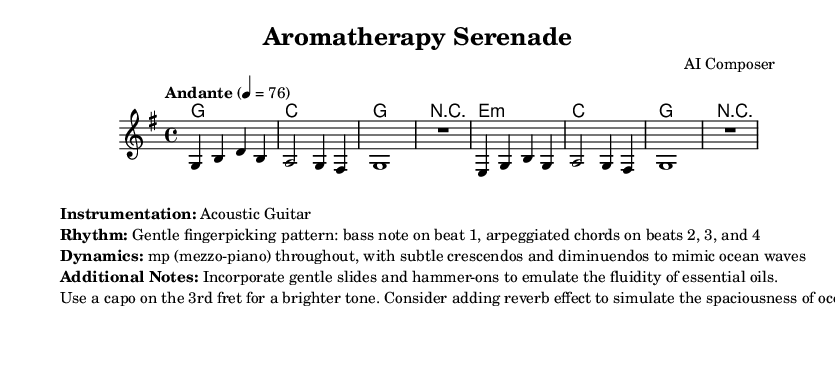What is the key signature of this music? The key signature is G major, which has one sharp (F#). This can be observed in the global settings of the sheet music.
Answer: G major What is the time signature of the piece? The time signature is 4/4, which indicates four beats per measure. This is specified in the global section of the code.
Answer: 4/4 What is the tempo marking for this sheet music? The tempo marking is "Andante," indicating a moderate pace. It is explicitly written in the global settings with a metronome marking of 76 beats per minute.
Answer: Andante What type of guitar playing style is indicated in the score? The piece is described as having a gentle fingerpicking pattern. This is detailed in the additional notes and serves to create a soft acoustic sound resembling ocean waves.
Answer: Fingerpicking What dynamic level is primarily used throughout the piece? The dynamics are indicated as mezzo-piano (mp), which means the music should be played moderately softly. This is mentioned in the additional notes section of the score.
Answer: Mezzo-piano How can the dynamics mimic ocean waves according to the additional notes? The additional notes state that there should be subtle crescendos and diminuendos throughout the piece, which refers to the gradual increases and decreases in volume, mimicking the ebb and flow of ocean waves.
Answer: Crescendos and diminuendos What effect is suggested to enhance the sound reminiscent of ocean waves? The use of reverb is suggested to simulate the spaciousness of ocean waves. This effect can create a more immersive listening experience, as mentioned in the additional notes.
Answer: Reverb 